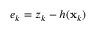<formula> <loc_0><loc_0><loc_500><loc_500>e _ { k } = z _ { k } - h ( x _ { k } )</formula> 